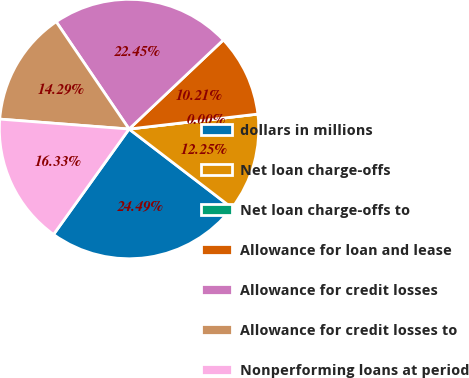Convert chart. <chart><loc_0><loc_0><loc_500><loc_500><pie_chart><fcel>dollars in millions<fcel>Net loan charge-offs<fcel>Net loan charge-offs to<fcel>Allowance for loan and lease<fcel>Allowance for credit losses<fcel>Allowance for credit losses to<fcel>Nonperforming loans at period<nl><fcel>24.49%<fcel>12.25%<fcel>0.0%<fcel>10.21%<fcel>22.45%<fcel>14.29%<fcel>16.33%<nl></chart> 